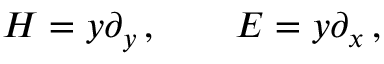Convert formula to latex. <formula><loc_0><loc_0><loc_500><loc_500>H = y \partial _ { y } \, , \quad E = y \partial _ { x } \, ,</formula> 